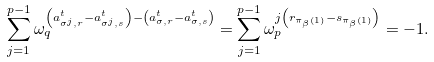<formula> <loc_0><loc_0><loc_500><loc_500>\sum _ { j = 1 } ^ { p - 1 } \omega _ { q } ^ { \left ( a ^ { t } _ { \sigma ^ { j } , r } - a ^ { t } _ { \sigma ^ { j } , s } \right ) - \left ( a ^ { t } _ { \sigma , r } - a ^ { t } _ { \sigma , s } \right ) } = \sum _ { j = 1 } ^ { p - 1 } \omega _ { p } ^ { j \left ( { r } _ { \pi _ { \beta } ( 1 ) } - { s } _ { \pi _ { \beta } ( 1 ) } \right ) } = - 1 .</formula> 